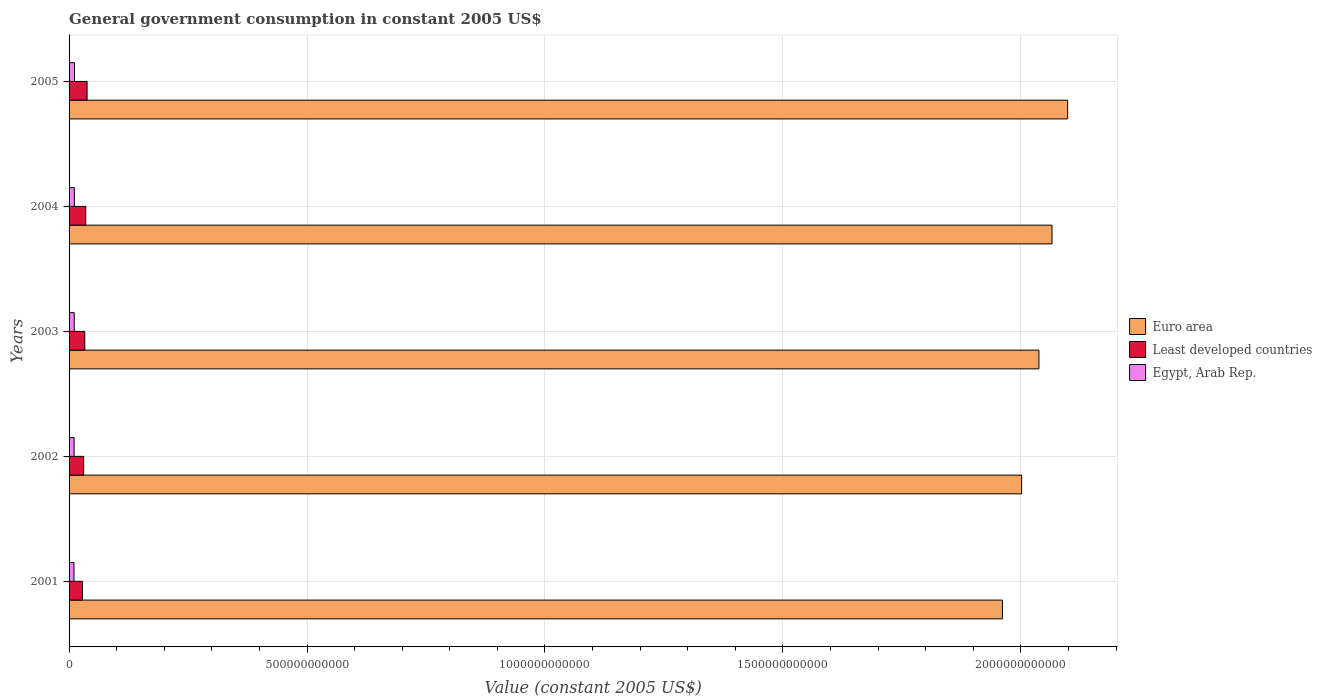Are the number of bars on each tick of the Y-axis equal?
Your answer should be very brief. Yes. How many bars are there on the 5th tick from the top?
Offer a terse response. 3. How many bars are there on the 2nd tick from the bottom?
Your answer should be compact. 3. In how many cases, is the number of bars for a given year not equal to the number of legend labels?
Your response must be concise. 0. What is the government conusmption in Egypt, Arab Rep. in 2001?
Give a very brief answer. 1.03e+1. Across all years, what is the maximum government conusmption in Euro area?
Your response must be concise. 2.10e+12. Across all years, what is the minimum government conusmption in Least developed countries?
Make the answer very short. 2.81e+1. In which year was the government conusmption in Least developed countries minimum?
Offer a terse response. 2001. What is the total government conusmption in Euro area in the graph?
Your answer should be compact. 1.02e+13. What is the difference between the government conusmption in Euro area in 2001 and that in 2002?
Give a very brief answer. -4.02e+1. What is the difference between the government conusmption in Euro area in 2004 and the government conusmption in Least developed countries in 2005?
Your answer should be compact. 2.03e+12. What is the average government conusmption in Egypt, Arab Rep. per year?
Your answer should be very brief. 1.09e+1. In the year 2001, what is the difference between the government conusmption in Egypt, Arab Rep. and government conusmption in Euro area?
Ensure brevity in your answer.  -1.95e+12. What is the ratio of the government conusmption in Least developed countries in 2001 to that in 2002?
Your response must be concise. 0.91. What is the difference between the highest and the second highest government conusmption in Least developed countries?
Make the answer very short. 2.81e+09. What is the difference between the highest and the lowest government conusmption in Euro area?
Your answer should be compact. 1.37e+11. What does the 1st bar from the top in 2004 represents?
Your response must be concise. Egypt, Arab Rep. What does the 3rd bar from the bottom in 2005 represents?
Provide a succinct answer. Egypt, Arab Rep. How many bars are there?
Give a very brief answer. 15. What is the difference between two consecutive major ticks on the X-axis?
Provide a succinct answer. 5.00e+11. Where does the legend appear in the graph?
Your response must be concise. Center right. How are the legend labels stacked?
Offer a very short reply. Vertical. What is the title of the graph?
Keep it short and to the point. General government consumption in constant 2005 US$. Does "Malta" appear as one of the legend labels in the graph?
Make the answer very short. No. What is the label or title of the X-axis?
Your response must be concise. Value (constant 2005 US$). What is the label or title of the Y-axis?
Your response must be concise. Years. What is the Value (constant 2005 US$) of Euro area in 2001?
Offer a terse response. 1.96e+12. What is the Value (constant 2005 US$) in Least developed countries in 2001?
Give a very brief answer. 2.81e+1. What is the Value (constant 2005 US$) of Egypt, Arab Rep. in 2001?
Give a very brief answer. 1.03e+1. What is the Value (constant 2005 US$) in Euro area in 2002?
Make the answer very short. 2.00e+12. What is the Value (constant 2005 US$) of Least developed countries in 2002?
Offer a terse response. 3.07e+1. What is the Value (constant 2005 US$) in Egypt, Arab Rep. in 2002?
Your answer should be compact. 1.06e+1. What is the Value (constant 2005 US$) in Euro area in 2003?
Offer a terse response. 2.04e+12. What is the Value (constant 2005 US$) in Least developed countries in 2003?
Your answer should be very brief. 3.30e+1. What is the Value (constant 2005 US$) of Egypt, Arab Rep. in 2003?
Keep it short and to the point. 1.09e+1. What is the Value (constant 2005 US$) in Euro area in 2004?
Offer a terse response. 2.07e+12. What is the Value (constant 2005 US$) in Least developed countries in 2004?
Your answer should be very brief. 3.51e+1. What is the Value (constant 2005 US$) in Egypt, Arab Rep. in 2004?
Make the answer very short. 1.11e+1. What is the Value (constant 2005 US$) in Euro area in 2005?
Keep it short and to the point. 2.10e+12. What is the Value (constant 2005 US$) of Least developed countries in 2005?
Give a very brief answer. 3.79e+1. What is the Value (constant 2005 US$) of Egypt, Arab Rep. in 2005?
Your response must be concise. 1.14e+1. Across all years, what is the maximum Value (constant 2005 US$) in Euro area?
Offer a very short reply. 2.10e+12. Across all years, what is the maximum Value (constant 2005 US$) of Least developed countries?
Ensure brevity in your answer.  3.79e+1. Across all years, what is the maximum Value (constant 2005 US$) of Egypt, Arab Rep.?
Offer a very short reply. 1.14e+1. Across all years, what is the minimum Value (constant 2005 US$) of Euro area?
Ensure brevity in your answer.  1.96e+12. Across all years, what is the minimum Value (constant 2005 US$) in Least developed countries?
Offer a very short reply. 2.81e+1. Across all years, what is the minimum Value (constant 2005 US$) in Egypt, Arab Rep.?
Provide a succinct answer. 1.03e+1. What is the total Value (constant 2005 US$) in Euro area in the graph?
Your answer should be compact. 1.02e+13. What is the total Value (constant 2005 US$) in Least developed countries in the graph?
Keep it short and to the point. 1.65e+11. What is the total Value (constant 2005 US$) in Egypt, Arab Rep. in the graph?
Your answer should be very brief. 5.44e+1. What is the difference between the Value (constant 2005 US$) in Euro area in 2001 and that in 2002?
Provide a short and direct response. -4.02e+1. What is the difference between the Value (constant 2005 US$) in Least developed countries in 2001 and that in 2002?
Ensure brevity in your answer.  -2.65e+09. What is the difference between the Value (constant 2005 US$) of Egypt, Arab Rep. in 2001 and that in 2002?
Your answer should be compact. -2.71e+08. What is the difference between the Value (constant 2005 US$) in Euro area in 2001 and that in 2003?
Keep it short and to the point. -7.67e+1. What is the difference between the Value (constant 2005 US$) in Least developed countries in 2001 and that in 2003?
Make the answer very short. -4.94e+09. What is the difference between the Value (constant 2005 US$) in Egypt, Arab Rep. in 2001 and that in 2003?
Offer a terse response. -5.60e+08. What is the difference between the Value (constant 2005 US$) of Euro area in 2001 and that in 2004?
Your answer should be compact. -1.04e+11. What is the difference between the Value (constant 2005 US$) in Least developed countries in 2001 and that in 2004?
Offer a terse response. -6.99e+09. What is the difference between the Value (constant 2005 US$) in Egypt, Arab Rep. in 2001 and that in 2004?
Your response must be concise. -7.83e+08. What is the difference between the Value (constant 2005 US$) of Euro area in 2001 and that in 2005?
Make the answer very short. -1.37e+11. What is the difference between the Value (constant 2005 US$) in Least developed countries in 2001 and that in 2005?
Your answer should be compact. -9.80e+09. What is the difference between the Value (constant 2005 US$) in Egypt, Arab Rep. in 2001 and that in 2005?
Provide a short and direct response. -1.09e+09. What is the difference between the Value (constant 2005 US$) in Euro area in 2002 and that in 2003?
Ensure brevity in your answer.  -3.64e+1. What is the difference between the Value (constant 2005 US$) in Least developed countries in 2002 and that in 2003?
Ensure brevity in your answer.  -2.29e+09. What is the difference between the Value (constant 2005 US$) in Egypt, Arab Rep. in 2002 and that in 2003?
Offer a terse response. -2.89e+08. What is the difference between the Value (constant 2005 US$) in Euro area in 2002 and that in 2004?
Keep it short and to the point. -6.39e+1. What is the difference between the Value (constant 2005 US$) of Least developed countries in 2002 and that in 2004?
Give a very brief answer. -4.34e+09. What is the difference between the Value (constant 2005 US$) in Egypt, Arab Rep. in 2002 and that in 2004?
Your response must be concise. -5.11e+08. What is the difference between the Value (constant 2005 US$) in Euro area in 2002 and that in 2005?
Make the answer very short. -9.68e+1. What is the difference between the Value (constant 2005 US$) of Least developed countries in 2002 and that in 2005?
Your response must be concise. -7.15e+09. What is the difference between the Value (constant 2005 US$) in Egypt, Arab Rep. in 2002 and that in 2005?
Your answer should be compact. -8.22e+08. What is the difference between the Value (constant 2005 US$) in Euro area in 2003 and that in 2004?
Offer a terse response. -2.75e+1. What is the difference between the Value (constant 2005 US$) of Least developed countries in 2003 and that in 2004?
Offer a very short reply. -2.05e+09. What is the difference between the Value (constant 2005 US$) in Egypt, Arab Rep. in 2003 and that in 2004?
Ensure brevity in your answer.  -2.22e+08. What is the difference between the Value (constant 2005 US$) in Euro area in 2003 and that in 2005?
Offer a very short reply. -6.03e+1. What is the difference between the Value (constant 2005 US$) in Least developed countries in 2003 and that in 2005?
Your response must be concise. -4.86e+09. What is the difference between the Value (constant 2005 US$) of Egypt, Arab Rep. in 2003 and that in 2005?
Ensure brevity in your answer.  -5.33e+08. What is the difference between the Value (constant 2005 US$) of Euro area in 2004 and that in 2005?
Your response must be concise. -3.29e+1. What is the difference between the Value (constant 2005 US$) of Least developed countries in 2004 and that in 2005?
Make the answer very short. -2.81e+09. What is the difference between the Value (constant 2005 US$) of Egypt, Arab Rep. in 2004 and that in 2005?
Your response must be concise. -3.11e+08. What is the difference between the Value (constant 2005 US$) in Euro area in 2001 and the Value (constant 2005 US$) in Least developed countries in 2002?
Provide a succinct answer. 1.93e+12. What is the difference between the Value (constant 2005 US$) in Euro area in 2001 and the Value (constant 2005 US$) in Egypt, Arab Rep. in 2002?
Your response must be concise. 1.95e+12. What is the difference between the Value (constant 2005 US$) of Least developed countries in 2001 and the Value (constant 2005 US$) of Egypt, Arab Rep. in 2002?
Provide a succinct answer. 1.75e+1. What is the difference between the Value (constant 2005 US$) in Euro area in 2001 and the Value (constant 2005 US$) in Least developed countries in 2003?
Your response must be concise. 1.93e+12. What is the difference between the Value (constant 2005 US$) in Euro area in 2001 and the Value (constant 2005 US$) in Egypt, Arab Rep. in 2003?
Give a very brief answer. 1.95e+12. What is the difference between the Value (constant 2005 US$) in Least developed countries in 2001 and the Value (constant 2005 US$) in Egypt, Arab Rep. in 2003?
Provide a short and direct response. 1.72e+1. What is the difference between the Value (constant 2005 US$) of Euro area in 2001 and the Value (constant 2005 US$) of Least developed countries in 2004?
Your answer should be very brief. 1.93e+12. What is the difference between the Value (constant 2005 US$) in Euro area in 2001 and the Value (constant 2005 US$) in Egypt, Arab Rep. in 2004?
Your answer should be very brief. 1.95e+12. What is the difference between the Value (constant 2005 US$) of Least developed countries in 2001 and the Value (constant 2005 US$) of Egypt, Arab Rep. in 2004?
Your response must be concise. 1.69e+1. What is the difference between the Value (constant 2005 US$) of Euro area in 2001 and the Value (constant 2005 US$) of Least developed countries in 2005?
Your answer should be compact. 1.92e+12. What is the difference between the Value (constant 2005 US$) in Euro area in 2001 and the Value (constant 2005 US$) in Egypt, Arab Rep. in 2005?
Keep it short and to the point. 1.95e+12. What is the difference between the Value (constant 2005 US$) in Least developed countries in 2001 and the Value (constant 2005 US$) in Egypt, Arab Rep. in 2005?
Provide a succinct answer. 1.66e+1. What is the difference between the Value (constant 2005 US$) of Euro area in 2002 and the Value (constant 2005 US$) of Least developed countries in 2003?
Your answer should be very brief. 1.97e+12. What is the difference between the Value (constant 2005 US$) in Euro area in 2002 and the Value (constant 2005 US$) in Egypt, Arab Rep. in 2003?
Provide a short and direct response. 1.99e+12. What is the difference between the Value (constant 2005 US$) of Least developed countries in 2002 and the Value (constant 2005 US$) of Egypt, Arab Rep. in 2003?
Keep it short and to the point. 1.98e+1. What is the difference between the Value (constant 2005 US$) in Euro area in 2002 and the Value (constant 2005 US$) in Least developed countries in 2004?
Provide a succinct answer. 1.97e+12. What is the difference between the Value (constant 2005 US$) of Euro area in 2002 and the Value (constant 2005 US$) of Egypt, Arab Rep. in 2004?
Your answer should be compact. 1.99e+12. What is the difference between the Value (constant 2005 US$) of Least developed countries in 2002 and the Value (constant 2005 US$) of Egypt, Arab Rep. in 2004?
Keep it short and to the point. 1.96e+1. What is the difference between the Value (constant 2005 US$) in Euro area in 2002 and the Value (constant 2005 US$) in Least developed countries in 2005?
Give a very brief answer. 1.96e+12. What is the difference between the Value (constant 2005 US$) of Euro area in 2002 and the Value (constant 2005 US$) of Egypt, Arab Rep. in 2005?
Provide a short and direct response. 1.99e+12. What is the difference between the Value (constant 2005 US$) of Least developed countries in 2002 and the Value (constant 2005 US$) of Egypt, Arab Rep. in 2005?
Make the answer very short. 1.93e+1. What is the difference between the Value (constant 2005 US$) in Euro area in 2003 and the Value (constant 2005 US$) in Least developed countries in 2004?
Offer a very short reply. 2.00e+12. What is the difference between the Value (constant 2005 US$) in Euro area in 2003 and the Value (constant 2005 US$) in Egypt, Arab Rep. in 2004?
Provide a short and direct response. 2.03e+12. What is the difference between the Value (constant 2005 US$) in Least developed countries in 2003 and the Value (constant 2005 US$) in Egypt, Arab Rep. in 2004?
Give a very brief answer. 2.19e+1. What is the difference between the Value (constant 2005 US$) in Euro area in 2003 and the Value (constant 2005 US$) in Least developed countries in 2005?
Give a very brief answer. 2.00e+12. What is the difference between the Value (constant 2005 US$) of Euro area in 2003 and the Value (constant 2005 US$) of Egypt, Arab Rep. in 2005?
Offer a very short reply. 2.03e+12. What is the difference between the Value (constant 2005 US$) of Least developed countries in 2003 and the Value (constant 2005 US$) of Egypt, Arab Rep. in 2005?
Provide a short and direct response. 2.16e+1. What is the difference between the Value (constant 2005 US$) of Euro area in 2004 and the Value (constant 2005 US$) of Least developed countries in 2005?
Your response must be concise. 2.03e+12. What is the difference between the Value (constant 2005 US$) of Euro area in 2004 and the Value (constant 2005 US$) of Egypt, Arab Rep. in 2005?
Give a very brief answer. 2.05e+12. What is the difference between the Value (constant 2005 US$) of Least developed countries in 2004 and the Value (constant 2005 US$) of Egypt, Arab Rep. in 2005?
Your answer should be compact. 2.36e+1. What is the average Value (constant 2005 US$) in Euro area per year?
Give a very brief answer. 2.03e+12. What is the average Value (constant 2005 US$) of Least developed countries per year?
Ensure brevity in your answer.  3.29e+1. What is the average Value (constant 2005 US$) of Egypt, Arab Rep. per year?
Provide a short and direct response. 1.09e+1. In the year 2001, what is the difference between the Value (constant 2005 US$) in Euro area and Value (constant 2005 US$) in Least developed countries?
Your response must be concise. 1.93e+12. In the year 2001, what is the difference between the Value (constant 2005 US$) of Euro area and Value (constant 2005 US$) of Egypt, Arab Rep.?
Ensure brevity in your answer.  1.95e+12. In the year 2001, what is the difference between the Value (constant 2005 US$) in Least developed countries and Value (constant 2005 US$) in Egypt, Arab Rep.?
Give a very brief answer. 1.77e+1. In the year 2002, what is the difference between the Value (constant 2005 US$) in Euro area and Value (constant 2005 US$) in Least developed countries?
Give a very brief answer. 1.97e+12. In the year 2002, what is the difference between the Value (constant 2005 US$) in Euro area and Value (constant 2005 US$) in Egypt, Arab Rep.?
Give a very brief answer. 1.99e+12. In the year 2002, what is the difference between the Value (constant 2005 US$) in Least developed countries and Value (constant 2005 US$) in Egypt, Arab Rep.?
Your answer should be very brief. 2.01e+1. In the year 2003, what is the difference between the Value (constant 2005 US$) of Euro area and Value (constant 2005 US$) of Least developed countries?
Make the answer very short. 2.00e+12. In the year 2003, what is the difference between the Value (constant 2005 US$) of Euro area and Value (constant 2005 US$) of Egypt, Arab Rep.?
Your answer should be very brief. 2.03e+12. In the year 2003, what is the difference between the Value (constant 2005 US$) in Least developed countries and Value (constant 2005 US$) in Egypt, Arab Rep.?
Make the answer very short. 2.21e+1. In the year 2004, what is the difference between the Value (constant 2005 US$) in Euro area and Value (constant 2005 US$) in Least developed countries?
Make the answer very short. 2.03e+12. In the year 2004, what is the difference between the Value (constant 2005 US$) of Euro area and Value (constant 2005 US$) of Egypt, Arab Rep.?
Provide a succinct answer. 2.05e+12. In the year 2004, what is the difference between the Value (constant 2005 US$) of Least developed countries and Value (constant 2005 US$) of Egypt, Arab Rep.?
Give a very brief answer. 2.39e+1. In the year 2005, what is the difference between the Value (constant 2005 US$) in Euro area and Value (constant 2005 US$) in Least developed countries?
Your answer should be very brief. 2.06e+12. In the year 2005, what is the difference between the Value (constant 2005 US$) in Euro area and Value (constant 2005 US$) in Egypt, Arab Rep.?
Provide a short and direct response. 2.09e+12. In the year 2005, what is the difference between the Value (constant 2005 US$) of Least developed countries and Value (constant 2005 US$) of Egypt, Arab Rep.?
Offer a very short reply. 2.64e+1. What is the ratio of the Value (constant 2005 US$) in Euro area in 2001 to that in 2002?
Your answer should be very brief. 0.98. What is the ratio of the Value (constant 2005 US$) in Least developed countries in 2001 to that in 2002?
Give a very brief answer. 0.91. What is the ratio of the Value (constant 2005 US$) of Egypt, Arab Rep. in 2001 to that in 2002?
Keep it short and to the point. 0.97. What is the ratio of the Value (constant 2005 US$) in Euro area in 2001 to that in 2003?
Provide a short and direct response. 0.96. What is the ratio of the Value (constant 2005 US$) of Least developed countries in 2001 to that in 2003?
Offer a very short reply. 0.85. What is the ratio of the Value (constant 2005 US$) of Egypt, Arab Rep. in 2001 to that in 2003?
Offer a terse response. 0.95. What is the ratio of the Value (constant 2005 US$) of Euro area in 2001 to that in 2004?
Offer a very short reply. 0.95. What is the ratio of the Value (constant 2005 US$) in Least developed countries in 2001 to that in 2004?
Provide a short and direct response. 0.8. What is the ratio of the Value (constant 2005 US$) of Egypt, Arab Rep. in 2001 to that in 2004?
Keep it short and to the point. 0.93. What is the ratio of the Value (constant 2005 US$) of Euro area in 2001 to that in 2005?
Give a very brief answer. 0.93. What is the ratio of the Value (constant 2005 US$) of Least developed countries in 2001 to that in 2005?
Provide a succinct answer. 0.74. What is the ratio of the Value (constant 2005 US$) in Egypt, Arab Rep. in 2001 to that in 2005?
Your answer should be compact. 0.9. What is the ratio of the Value (constant 2005 US$) of Euro area in 2002 to that in 2003?
Provide a succinct answer. 0.98. What is the ratio of the Value (constant 2005 US$) in Least developed countries in 2002 to that in 2003?
Offer a terse response. 0.93. What is the ratio of the Value (constant 2005 US$) in Egypt, Arab Rep. in 2002 to that in 2003?
Give a very brief answer. 0.97. What is the ratio of the Value (constant 2005 US$) in Euro area in 2002 to that in 2004?
Give a very brief answer. 0.97. What is the ratio of the Value (constant 2005 US$) of Least developed countries in 2002 to that in 2004?
Make the answer very short. 0.88. What is the ratio of the Value (constant 2005 US$) of Egypt, Arab Rep. in 2002 to that in 2004?
Offer a terse response. 0.95. What is the ratio of the Value (constant 2005 US$) in Euro area in 2002 to that in 2005?
Offer a terse response. 0.95. What is the ratio of the Value (constant 2005 US$) in Least developed countries in 2002 to that in 2005?
Offer a terse response. 0.81. What is the ratio of the Value (constant 2005 US$) of Egypt, Arab Rep. in 2002 to that in 2005?
Keep it short and to the point. 0.93. What is the ratio of the Value (constant 2005 US$) in Euro area in 2003 to that in 2004?
Provide a short and direct response. 0.99. What is the ratio of the Value (constant 2005 US$) in Least developed countries in 2003 to that in 2004?
Ensure brevity in your answer.  0.94. What is the ratio of the Value (constant 2005 US$) of Euro area in 2003 to that in 2005?
Provide a short and direct response. 0.97. What is the ratio of the Value (constant 2005 US$) of Least developed countries in 2003 to that in 2005?
Offer a very short reply. 0.87. What is the ratio of the Value (constant 2005 US$) in Egypt, Arab Rep. in 2003 to that in 2005?
Keep it short and to the point. 0.95. What is the ratio of the Value (constant 2005 US$) in Euro area in 2004 to that in 2005?
Offer a terse response. 0.98. What is the ratio of the Value (constant 2005 US$) of Least developed countries in 2004 to that in 2005?
Offer a very short reply. 0.93. What is the ratio of the Value (constant 2005 US$) of Egypt, Arab Rep. in 2004 to that in 2005?
Keep it short and to the point. 0.97. What is the difference between the highest and the second highest Value (constant 2005 US$) of Euro area?
Offer a terse response. 3.29e+1. What is the difference between the highest and the second highest Value (constant 2005 US$) in Least developed countries?
Your answer should be compact. 2.81e+09. What is the difference between the highest and the second highest Value (constant 2005 US$) in Egypt, Arab Rep.?
Your answer should be compact. 3.11e+08. What is the difference between the highest and the lowest Value (constant 2005 US$) in Euro area?
Keep it short and to the point. 1.37e+11. What is the difference between the highest and the lowest Value (constant 2005 US$) of Least developed countries?
Offer a very short reply. 9.80e+09. What is the difference between the highest and the lowest Value (constant 2005 US$) of Egypt, Arab Rep.?
Keep it short and to the point. 1.09e+09. 